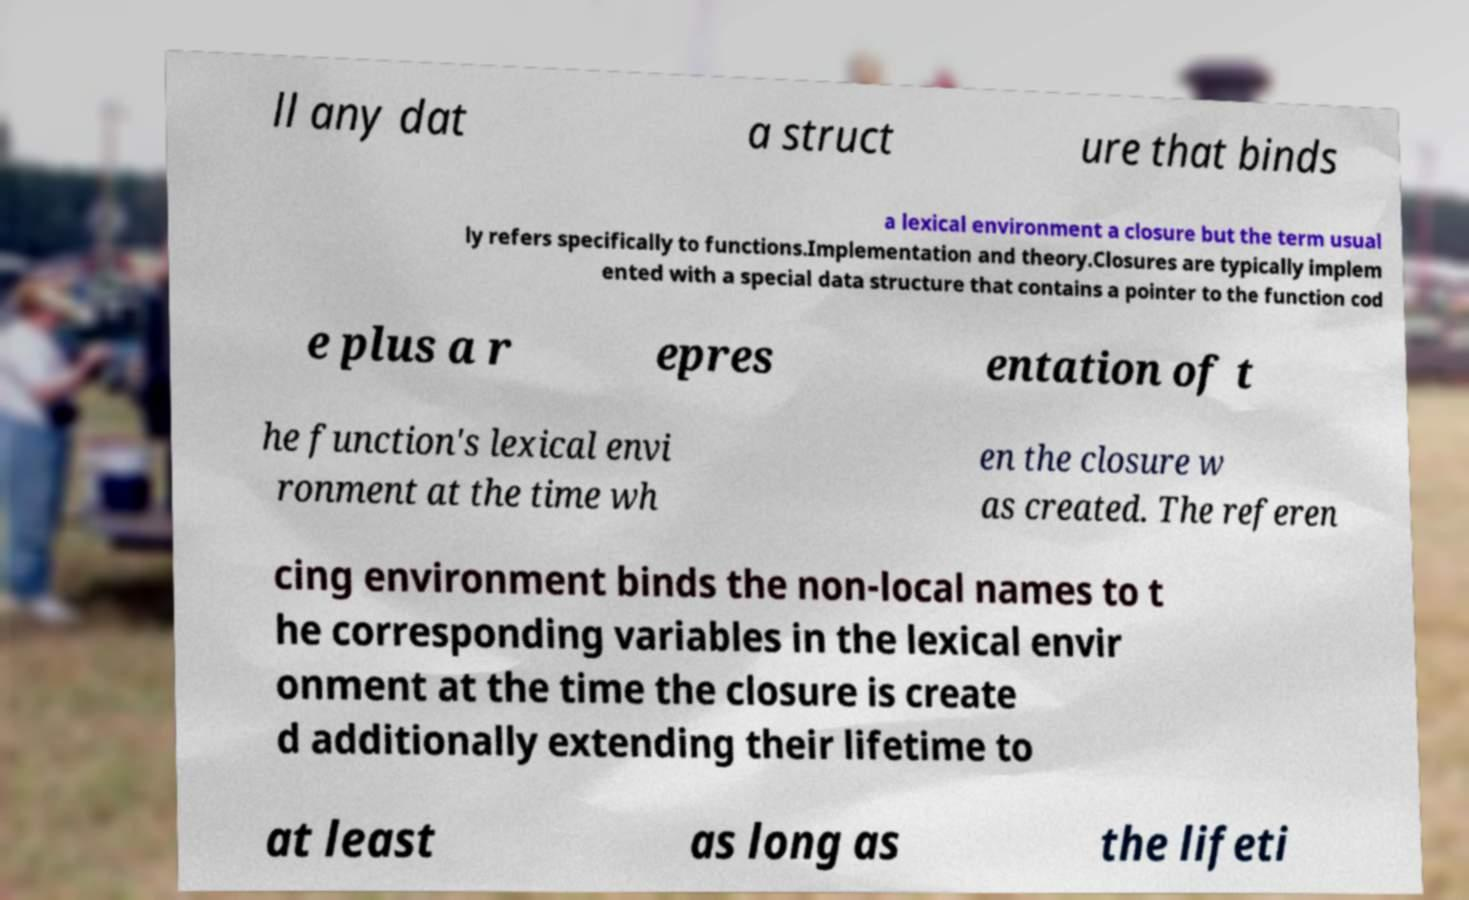Please identify and transcribe the text found in this image. ll any dat a struct ure that binds a lexical environment a closure but the term usual ly refers specifically to functions.Implementation and theory.Closures are typically implem ented with a special data structure that contains a pointer to the function cod e plus a r epres entation of t he function's lexical envi ronment at the time wh en the closure w as created. The referen cing environment binds the non-local names to t he corresponding variables in the lexical envir onment at the time the closure is create d additionally extending their lifetime to at least as long as the lifeti 